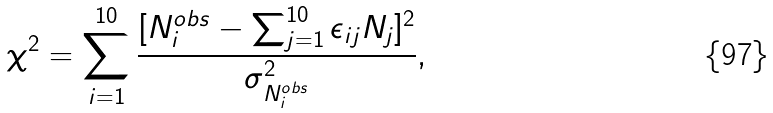Convert formula to latex. <formula><loc_0><loc_0><loc_500><loc_500>\chi ^ { 2 } = \sum _ { i = 1 } ^ { 1 0 } \frac { [ N _ { i } ^ { o b s } - \sum _ { j = 1 } ^ { 1 0 } \epsilon _ { i j } N _ { j } ] ^ { 2 } } { \sigma _ { N _ { i } ^ { o b s } } ^ { 2 } } ,</formula> 